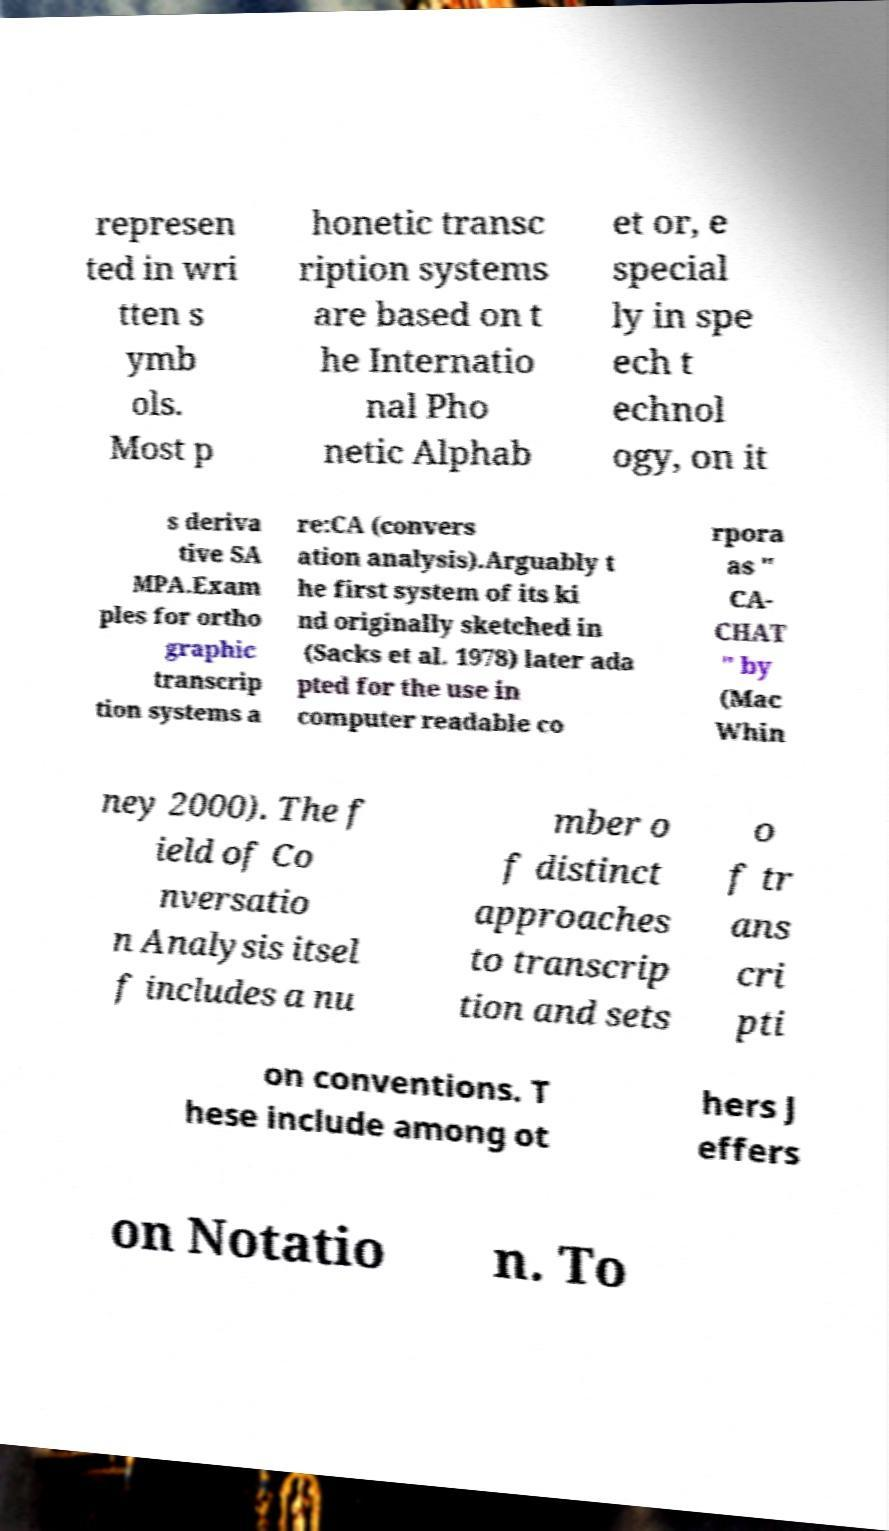I need the written content from this picture converted into text. Can you do that? represen ted in wri tten s ymb ols. Most p honetic transc ription systems are based on t he Internatio nal Pho netic Alphab et or, e special ly in spe ech t echnol ogy, on it s deriva tive SA MPA.Exam ples for ortho graphic transcrip tion systems a re:CA (convers ation analysis).Arguably t he first system of its ki nd originally sketched in (Sacks et al. 1978) later ada pted for the use in computer readable co rpora as " CA- CHAT " by (Mac Whin ney 2000). The f ield of Co nversatio n Analysis itsel f includes a nu mber o f distinct approaches to transcrip tion and sets o f tr ans cri pti on conventions. T hese include among ot hers J effers on Notatio n. To 